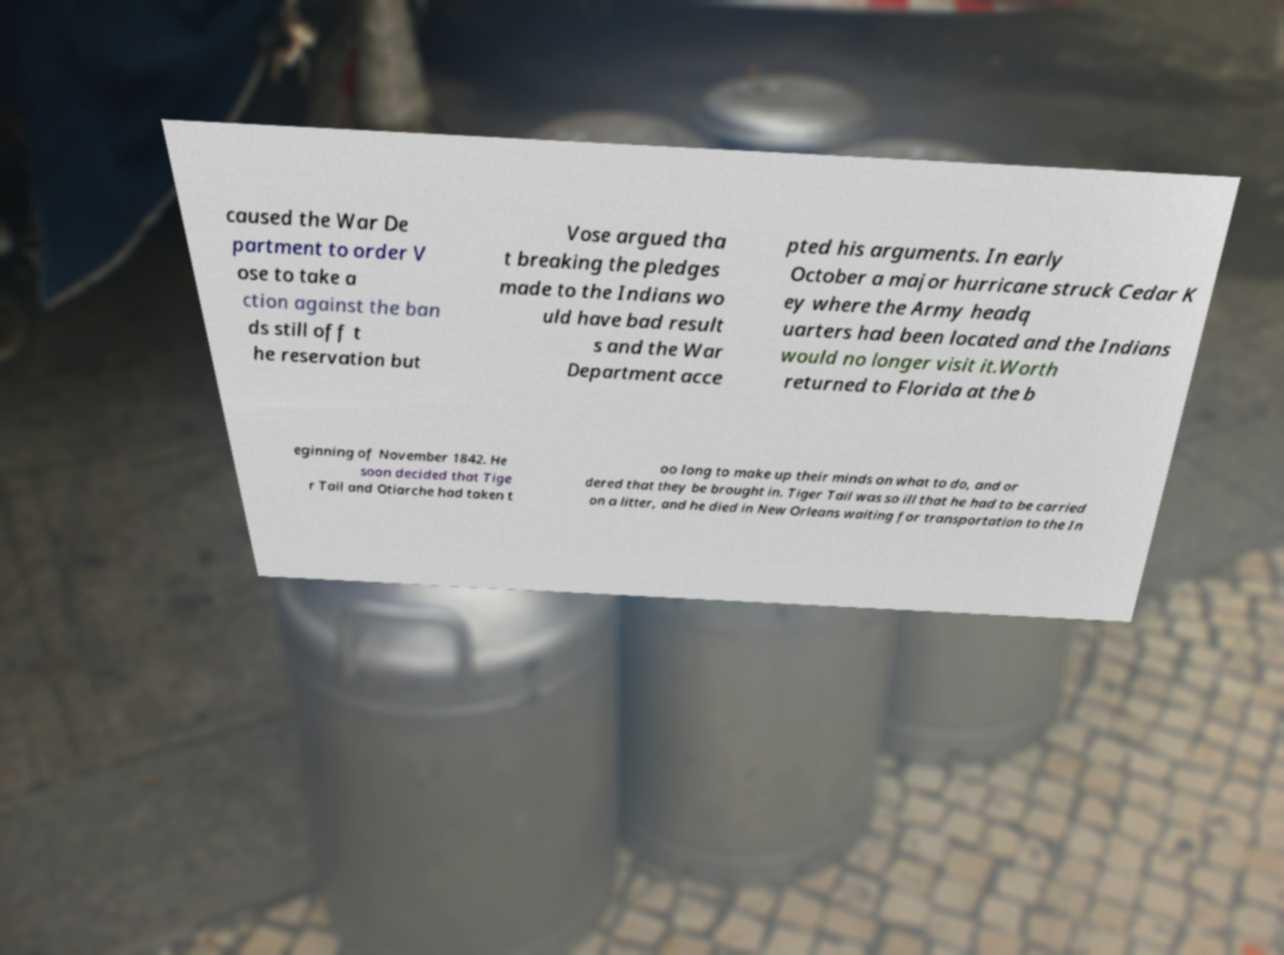Please read and relay the text visible in this image. What does it say? caused the War De partment to order V ose to take a ction against the ban ds still off t he reservation but Vose argued tha t breaking the pledges made to the Indians wo uld have bad result s and the War Department acce pted his arguments. In early October a major hurricane struck Cedar K ey where the Army headq uarters had been located and the Indians would no longer visit it.Worth returned to Florida at the b eginning of November 1842. He soon decided that Tige r Tail and Otiarche had taken t oo long to make up their minds on what to do, and or dered that they be brought in. Tiger Tail was so ill that he had to be carried on a litter, and he died in New Orleans waiting for transportation to the In 